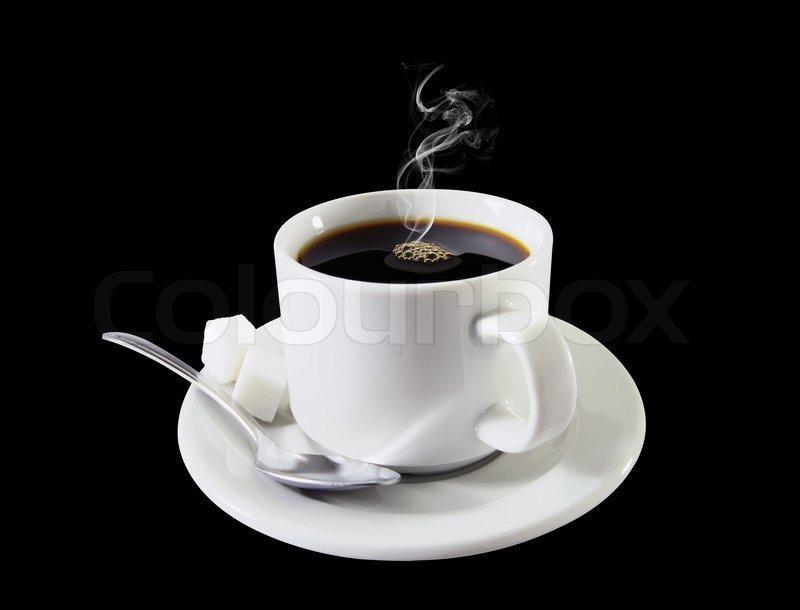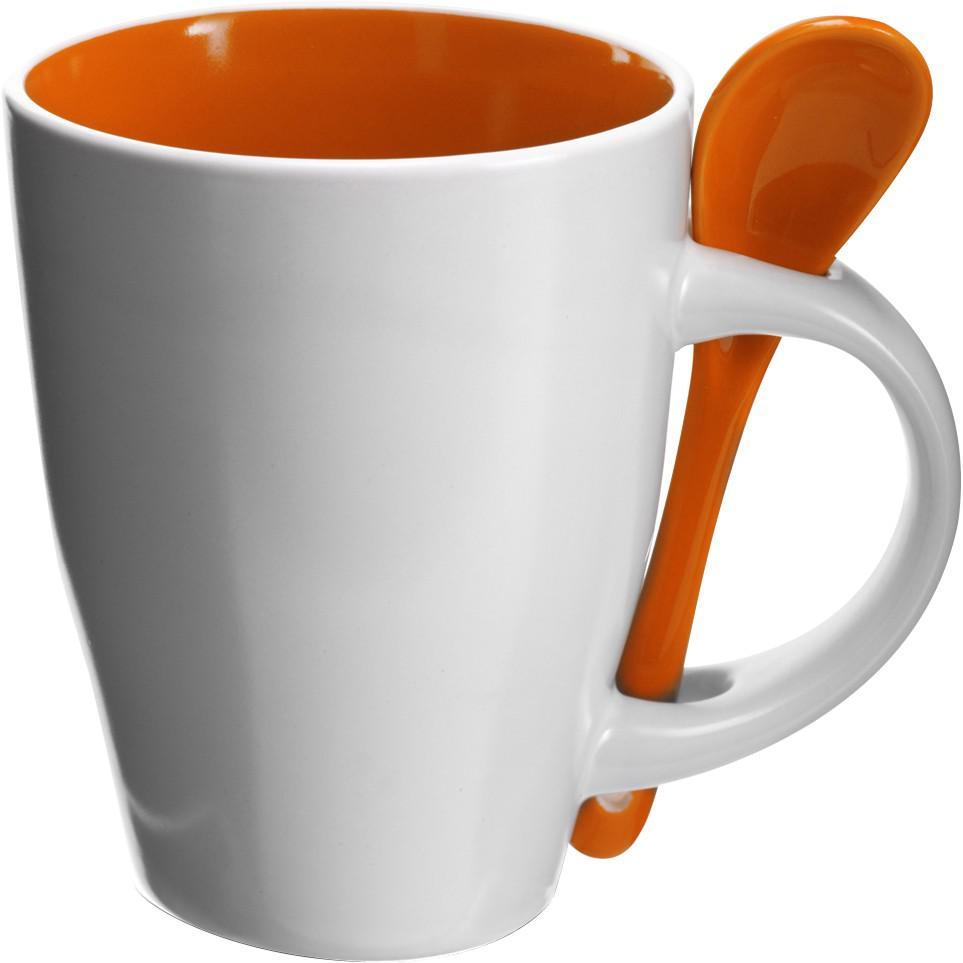The first image is the image on the left, the second image is the image on the right. Examine the images to the left and right. Is the description "There is at least one orange spoon in the image on the right." accurate? Answer yes or no. Yes. 